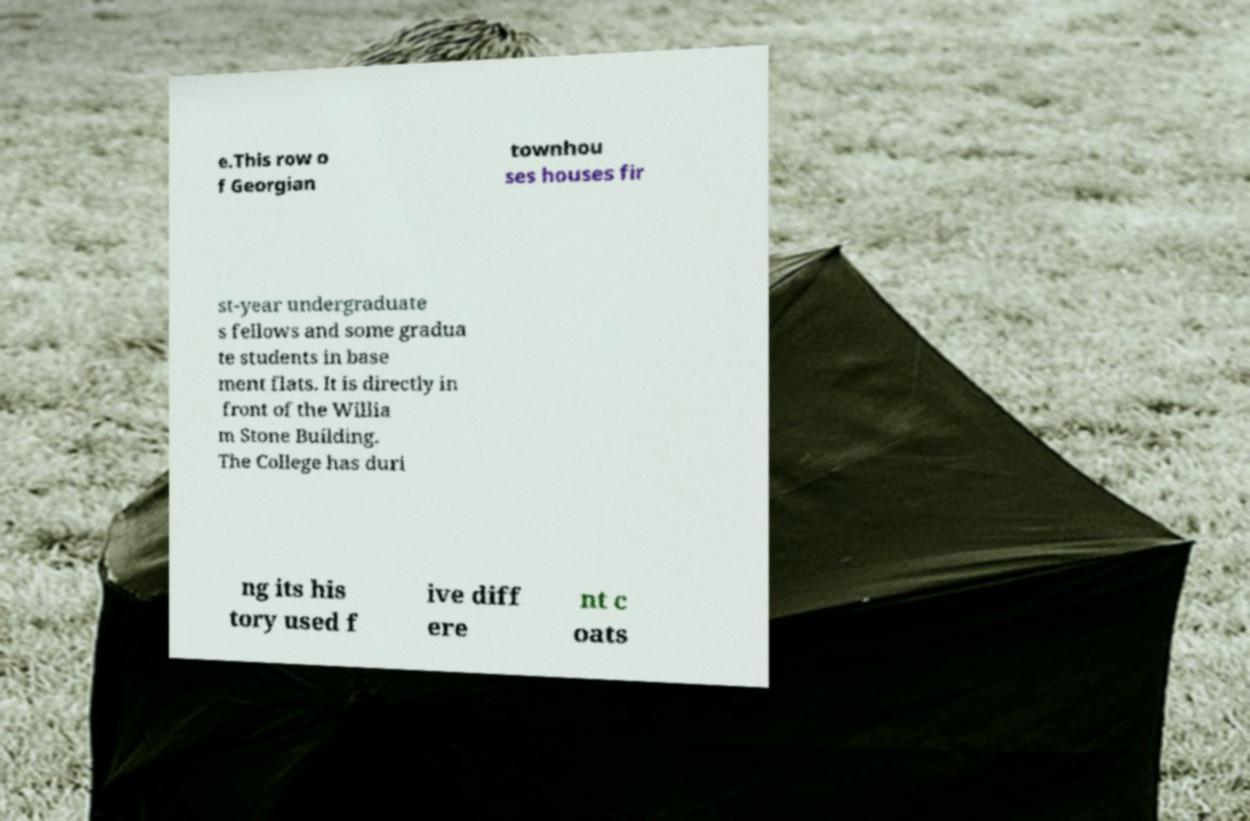There's text embedded in this image that I need extracted. Can you transcribe it verbatim? e.This row o f Georgian townhou ses houses fir st-year undergraduate s fellows and some gradua te students in base ment flats. It is directly in front of the Willia m Stone Building. The College has duri ng its his tory used f ive diff ere nt c oats 